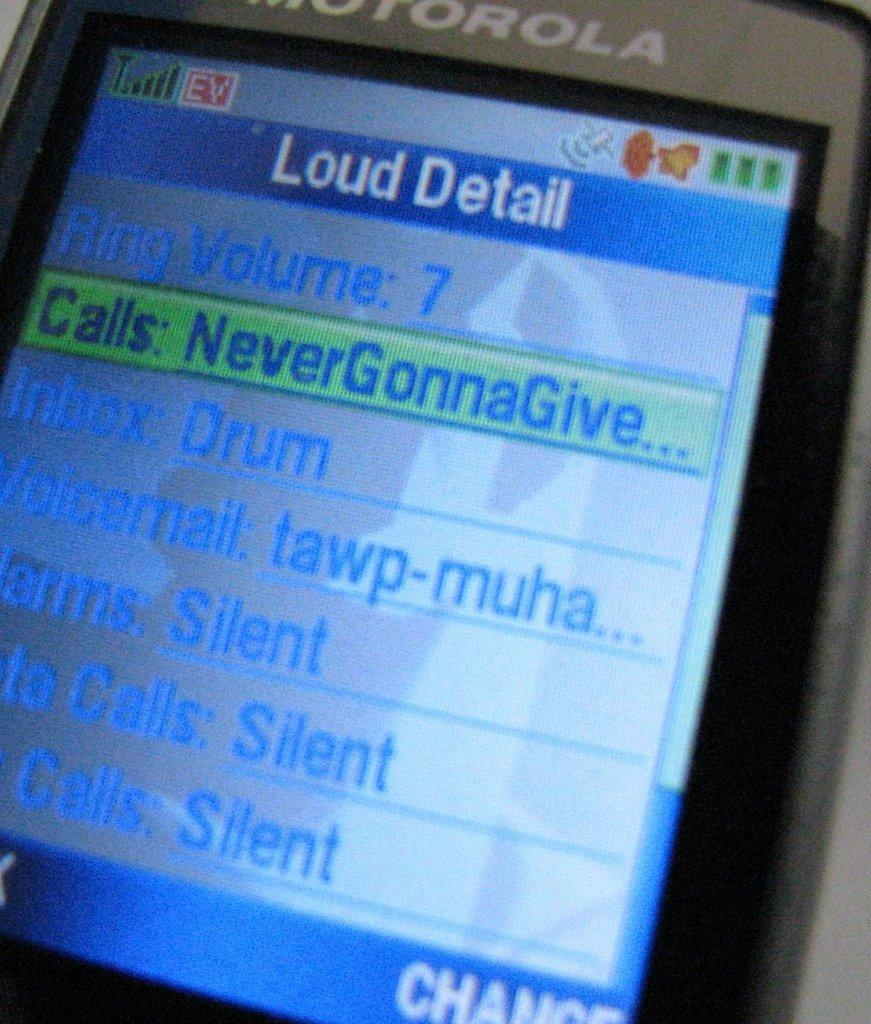Provide a one-sentence caption for the provided image. a picture of a phone screen looking at ringer volume and ringer sounds. 